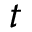<formula> <loc_0><loc_0><loc_500><loc_500>t</formula> 